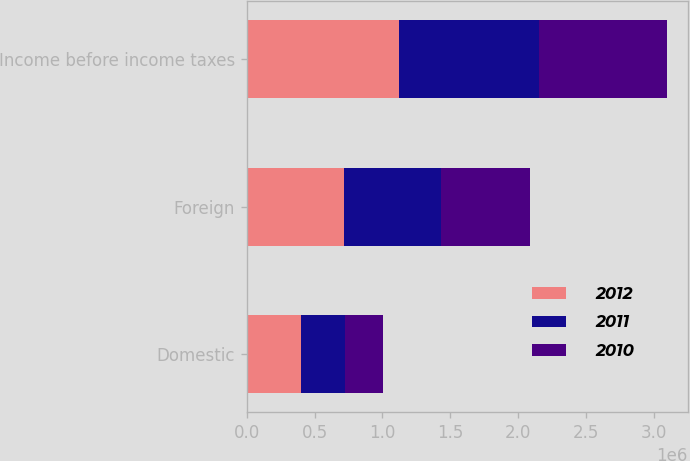<chart> <loc_0><loc_0><loc_500><loc_500><stacked_bar_chart><ecel><fcel>Domestic<fcel>Foreign<fcel>Income before income taxes<nl><fcel>2012<fcel>402723<fcel>716071<fcel>1.11879e+06<nl><fcel>2011<fcel>319500<fcel>715730<fcel>1.03523e+06<nl><fcel>2010<fcel>283819<fcel>659332<fcel>943151<nl></chart> 